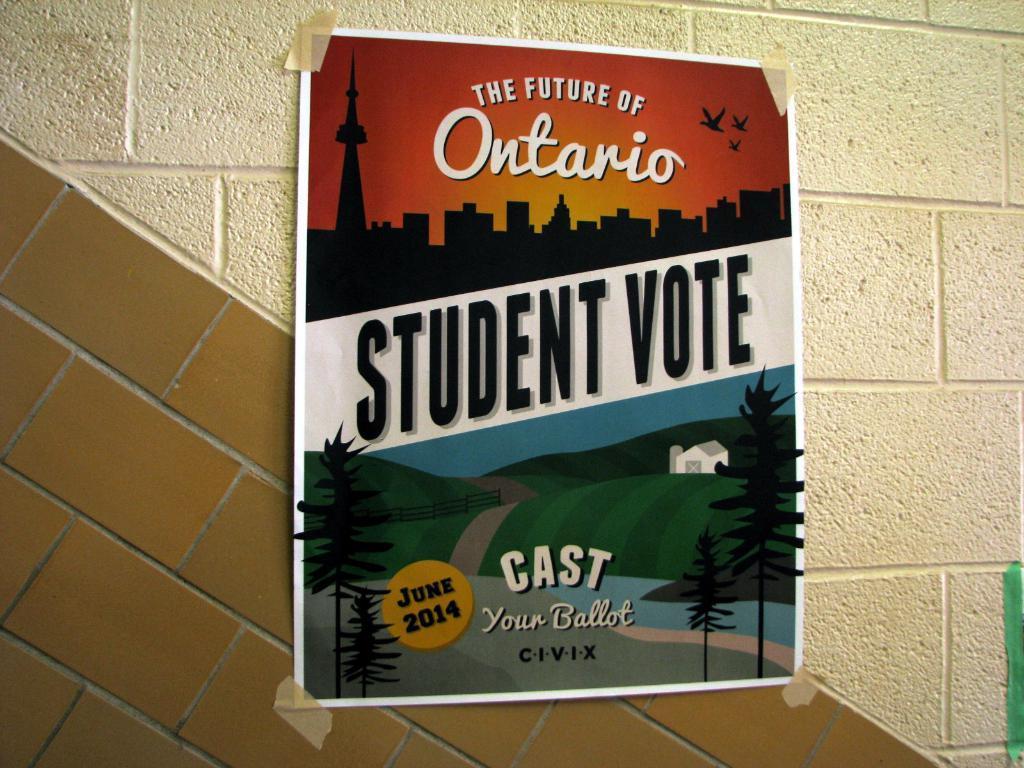How would you summarize this image in a sentence or two? In the middle of the image, there is a poster having two images and texts posted on the wall. And this wall is having two colors. 